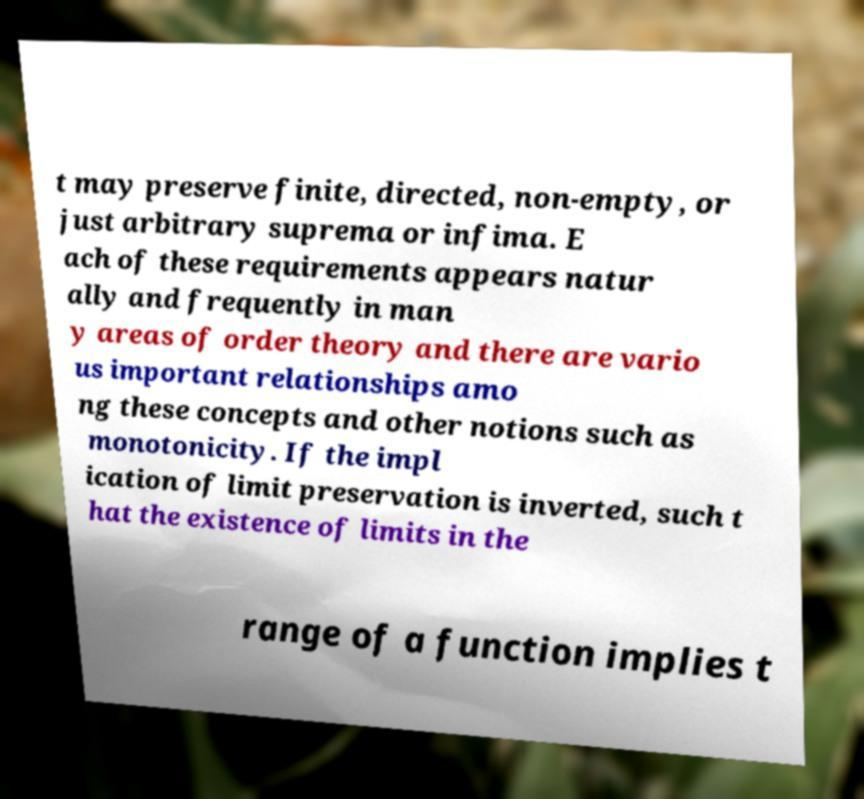I need the written content from this picture converted into text. Can you do that? t may preserve finite, directed, non-empty, or just arbitrary suprema or infima. E ach of these requirements appears natur ally and frequently in man y areas of order theory and there are vario us important relationships amo ng these concepts and other notions such as monotonicity. If the impl ication of limit preservation is inverted, such t hat the existence of limits in the range of a function implies t 